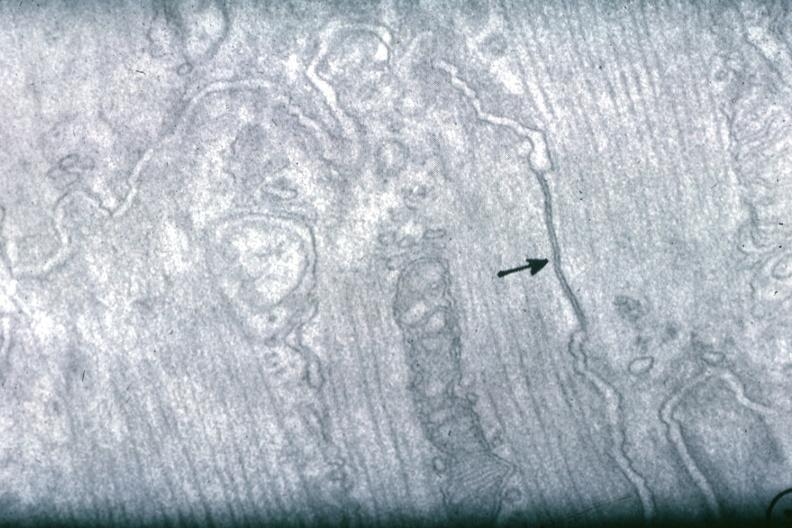s lymphangiomatosis generalized present?
Answer the question using a single word or phrase. No 